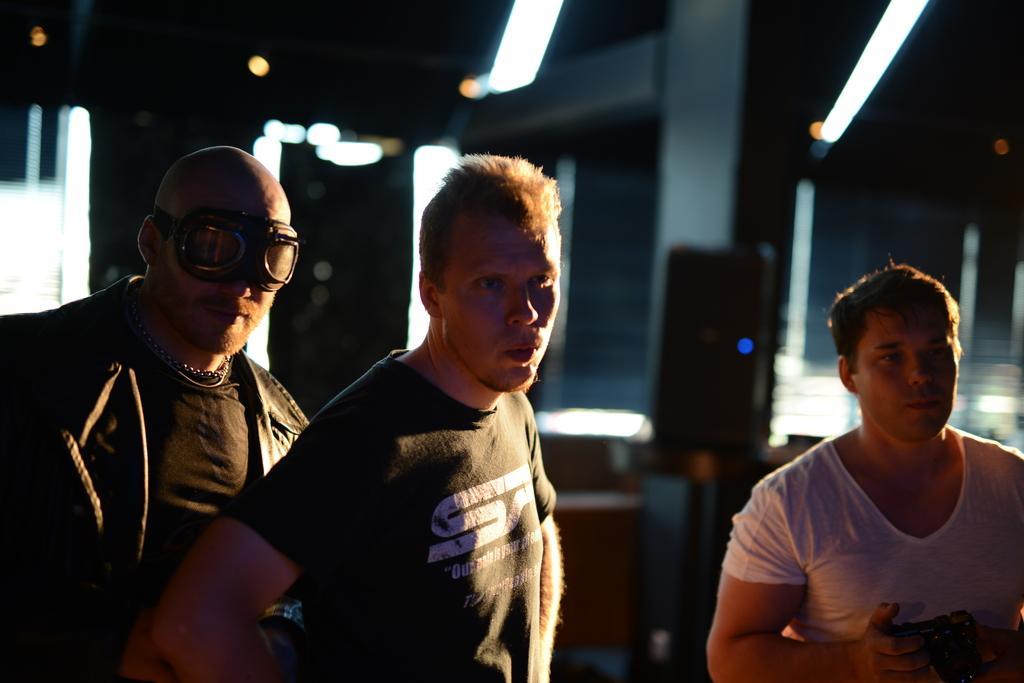Could you give a brief overview of what you see in this image? In this image we can see three persons and among them a person is holding a camera. The background of the image is blurred. 